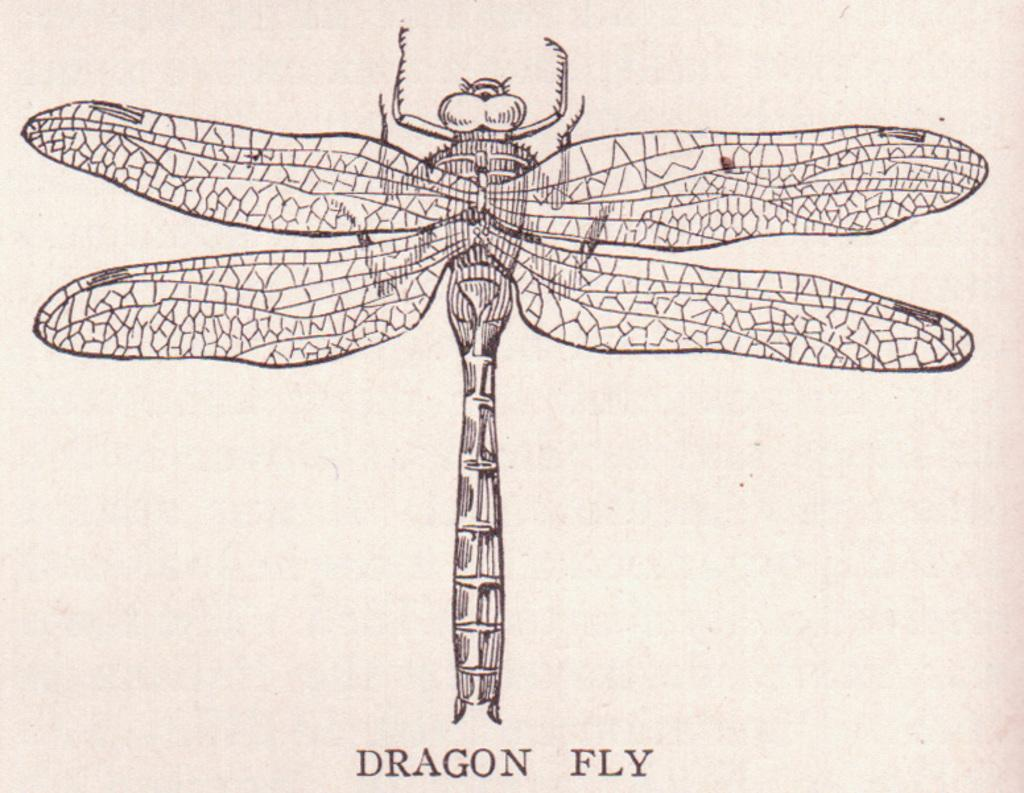What is the main subject of the image? The main subject of the image is a picture of a dragonfly. What else is featured in the image besides the picture of the dragonfly? There is text below the picture in the image. What type of air can be seen in the image? There is no air visible in the image; it features a picture of a dragonfly and text below it. Who is the achiever being recognized in the image? There is no reference to an achiever or any recognition in the image. 